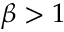Convert formula to latex. <formula><loc_0><loc_0><loc_500><loc_500>\beta > 1</formula> 